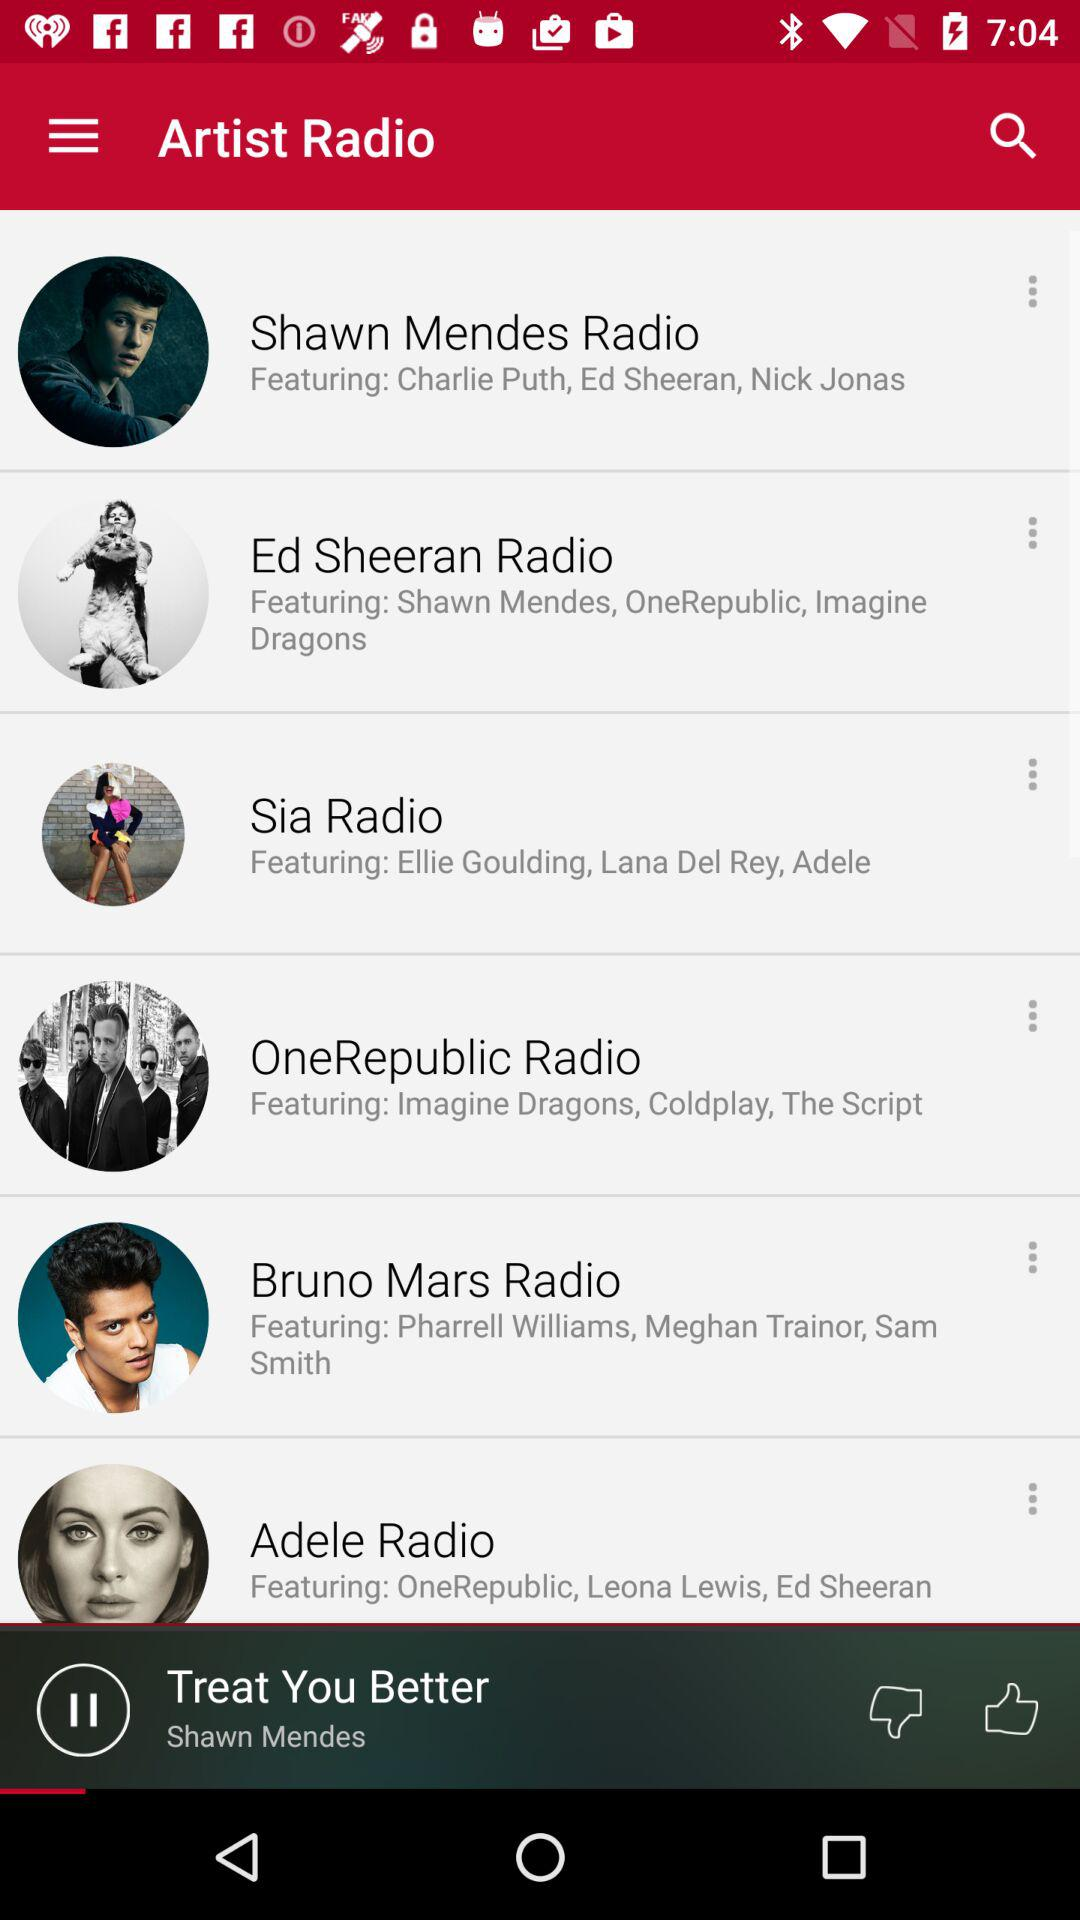How many radio stations are featured on the screen?
Answer the question using a single word or phrase. 6 